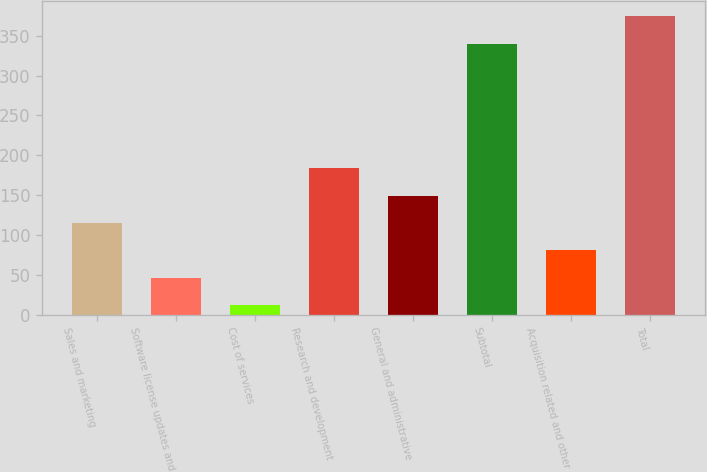<chart> <loc_0><loc_0><loc_500><loc_500><bar_chart><fcel>Sales and marketing<fcel>Software license updates and<fcel>Cost of services<fcel>Research and development<fcel>General and administrative<fcel>Subtotal<fcel>Acquisition related and other<fcel>Total<nl><fcel>114.9<fcel>46.3<fcel>12<fcel>183.5<fcel>149.2<fcel>340<fcel>80.6<fcel>374.3<nl></chart> 